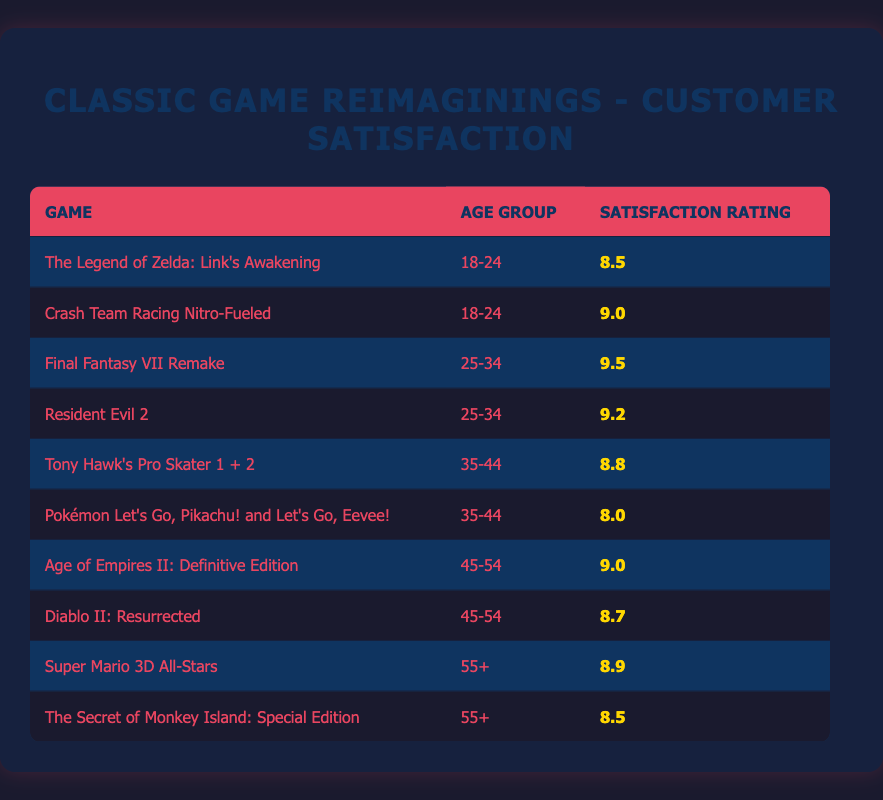What is the satisfaction rating for "Crash Team Racing Nitro-Fueled" among the 18-24 age group? The table displays the satisfaction rating for each game based on the age group. Looking for "Crash Team Racing Nitro-Fueled" in the 18-24 age group, the rating is 9.0.
Answer: 9.0 Which game has the highest satisfaction rating among the age group 25-34? The games listed for the age group 25-34 are "Final Fantasy VII Remake" with a rating of 9.5 and "Resident Evil 2" with a rating of 9.2. Comparing these, "Final Fantasy VII Remake" has the highest rating.
Answer: Final Fantasy VII Remake Is the average satisfaction rating for games in the age group 35-44 higher than that for games in the age group 45-54? The ratings for age group 35-44 are 8.8 and 8.0, giving an average of (8.8 + 8.0) / 2 = 8.4. For age group 45-54, the ratings are 9.0 and 8.7, with an average of (9.0 + 8.7) / 2 = 8.85. Since 8.4 < 8.85, it means the average for 35-44 is not higher.
Answer: No Are there any games rated below 9.0 among the age group 45-54? Looking through the games in the 45-54 age group, "Diablo II: Resurrected" has a rating of 8.7, which is below 9.0. Thus, there is at least one game rated below that threshold.
Answer: Yes What is the difference in satisfaction ratings between "Tony Hawk's Pro Skater 1 + 2" and "Pokémon Let's Go, Pikachu! and Let's Go, Eevee!"? The satisfaction rating for "Tony Hawk's Pro Skater 1 + 2" is 8.8, and for "Pokémon Let's Go, Pikachu! and Let's Go, Eevee!" it is 8.0. The difference is calculated as 8.8 - 8.0 = 0.8.
Answer: 0.8 How many games have a satisfaction rating of 8.5 or higher among all age groups? Counting the ratings that are 8.5 or higher in the table: "The Legend of Zelda: Link's Awakening" (8.5), "Crash Team Racing Nitro-Fueled" (9.0), "Final Fantasy VII Remake" (9.5), "Resident Evil 2" (9.2), "Tony Hawk's Pro Skater 1 + 2" (8.8), "Age of Empires II: Definitive Edition" (9.0), "Super Mario 3D All-Stars" (8.9), and "The Secret of Monkey Island: Special Edition" (8.5) gives us a total of 8 games rated 8.5 or above.
Answer: 8 Is "Resident Evil 2" rated higher among the 25-34 age group than "Diablo II: Resurrected" in the 45-54 age group? "Resident Evil 2" has a rating of 9.2, whereas "Diablo II: Resurrected" is rated at 8.7. Comparing these, 9.2 is indeed higher than 8.7.
Answer: Yes 